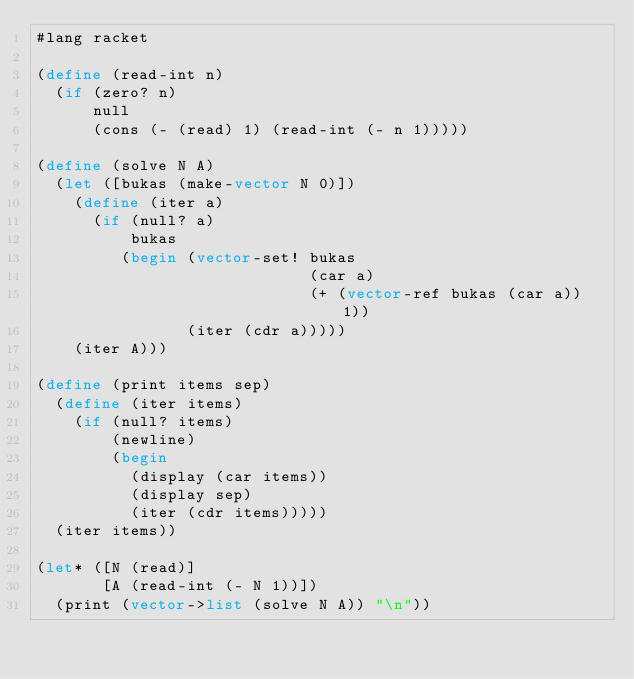<code> <loc_0><loc_0><loc_500><loc_500><_Racket_>#lang racket

(define (read-int n)
  (if (zero? n)
      null
      (cons (- (read) 1) (read-int (- n 1)))))

(define (solve N A)
  (let ([bukas (make-vector N 0)])
    (define (iter a)
      (if (null? a)
          bukas
         (begin (vector-set! bukas
                             (car a)
                             (+ (vector-ref bukas (car a)) 1))
                (iter (cdr a)))))
    (iter A)))
    
(define (print items sep)
  (define (iter items)
    (if (null? items)
        (newline)
        (begin
          (display (car items))
          (display sep)
          (iter (cdr items)))))
  (iter items))

(let* ([N (read)]
       [A (read-int (- N 1))])
  (print (vector->list (solve N A)) "\n"))
  
</code> 